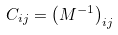Convert formula to latex. <formula><loc_0><loc_0><loc_500><loc_500>C _ { i j } = \left ( M ^ { - 1 } \right ) _ { i j }</formula> 